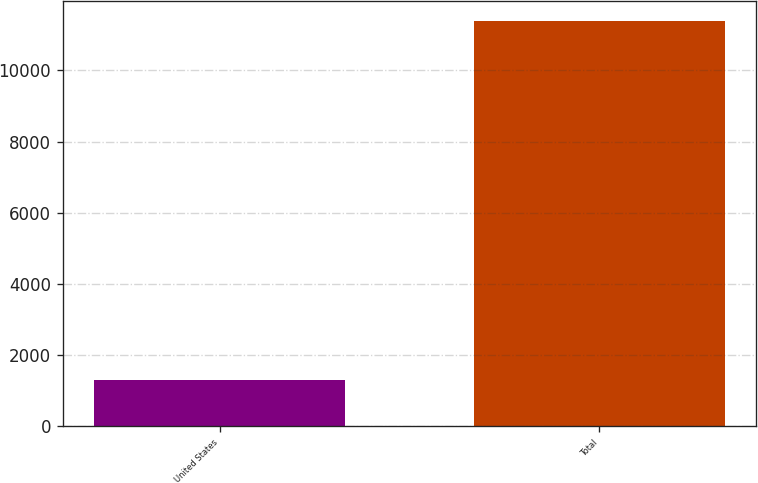Convert chart. <chart><loc_0><loc_0><loc_500><loc_500><bar_chart><fcel>United States<fcel>Total<nl><fcel>1293<fcel>11380<nl></chart> 